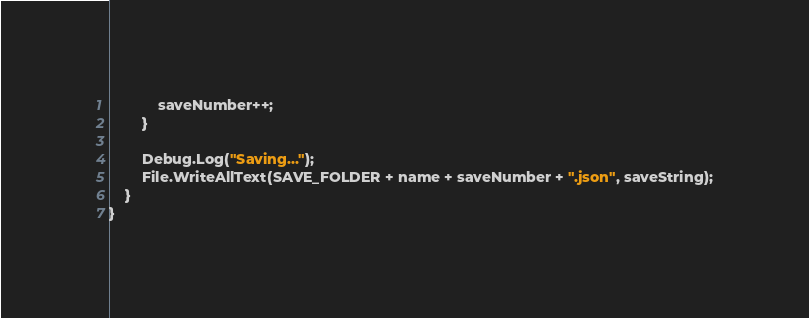Convert code to text. <code><loc_0><loc_0><loc_500><loc_500><_C#_>            saveNumber++;
        }

        Debug.Log("Saving...");
        File.WriteAllText(SAVE_FOLDER + name + saveNumber + ".json", saveString);
    }
}
</code> 